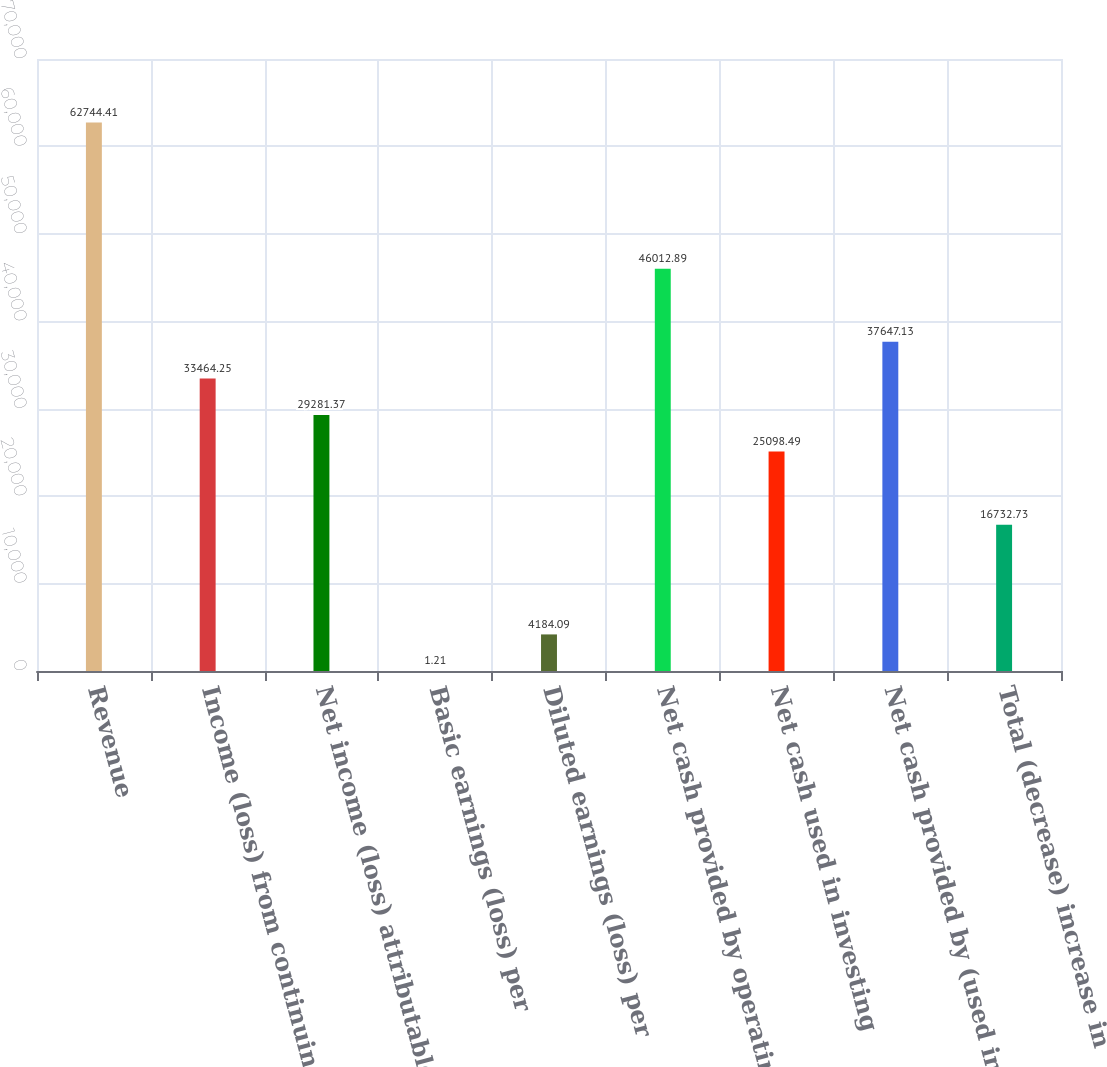Convert chart to OTSL. <chart><loc_0><loc_0><loc_500><loc_500><bar_chart><fcel>Revenue<fcel>Income (loss) from continuing<fcel>Net income (loss) attributable<fcel>Basic earnings (loss) per<fcel>Diluted earnings (loss) per<fcel>Net cash provided by operating<fcel>Net cash used in investing<fcel>Net cash provided by (used in)<fcel>Total (decrease) increase in<nl><fcel>62744.4<fcel>33464.2<fcel>29281.4<fcel>1.21<fcel>4184.09<fcel>46012.9<fcel>25098.5<fcel>37647.1<fcel>16732.7<nl></chart> 